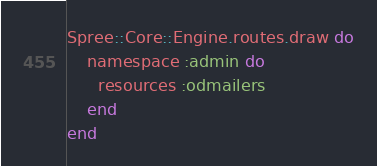Convert code to text. <code><loc_0><loc_0><loc_500><loc_500><_Ruby_>Spree::Core::Engine.routes.draw do
    namespace :admin do
      resources :odmailers
    end
end
</code> 